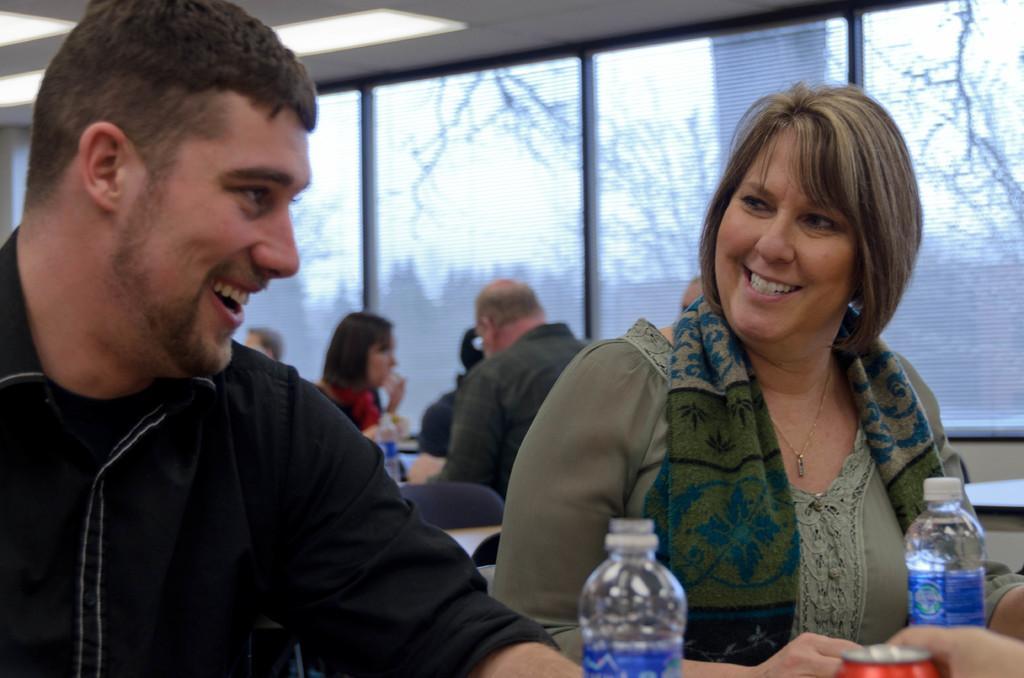Please provide a concise description of this image. In this image there is a man and woman smiling and a water bottle , tin and at the back ground there are group of people sitting , trees, and a glass. 